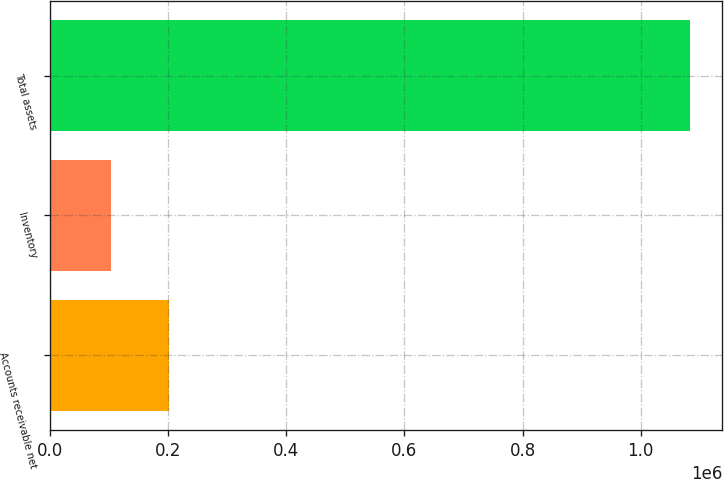Convert chart. <chart><loc_0><loc_0><loc_500><loc_500><bar_chart><fcel>Accounts receivable net<fcel>Inventory<fcel>Total assets<nl><fcel>202147<fcel>104235<fcel>1.08335e+06<nl></chart> 